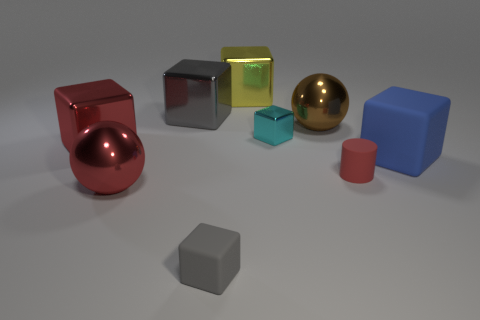Subtract all blue blocks. How many blocks are left? 5 Subtract all cubes. How many objects are left? 3 Subtract 2 balls. How many balls are left? 0 Add 3 yellow metallic things. How many yellow metallic things exist? 4 Add 1 big yellow cubes. How many objects exist? 10 Subtract all gray cubes. How many cubes are left? 4 Subtract 1 cyan cubes. How many objects are left? 8 Subtract all green cylinders. Subtract all brown cubes. How many cylinders are left? 1 Subtract all cyan cubes. How many brown balls are left? 1 Subtract all small red objects. Subtract all big red metallic spheres. How many objects are left? 7 